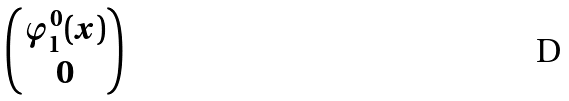<formula> <loc_0><loc_0><loc_500><loc_500>\begin{pmatrix} \varphi ^ { 0 } _ { 1 } ( x ) \\ 0 \end{pmatrix}</formula> 